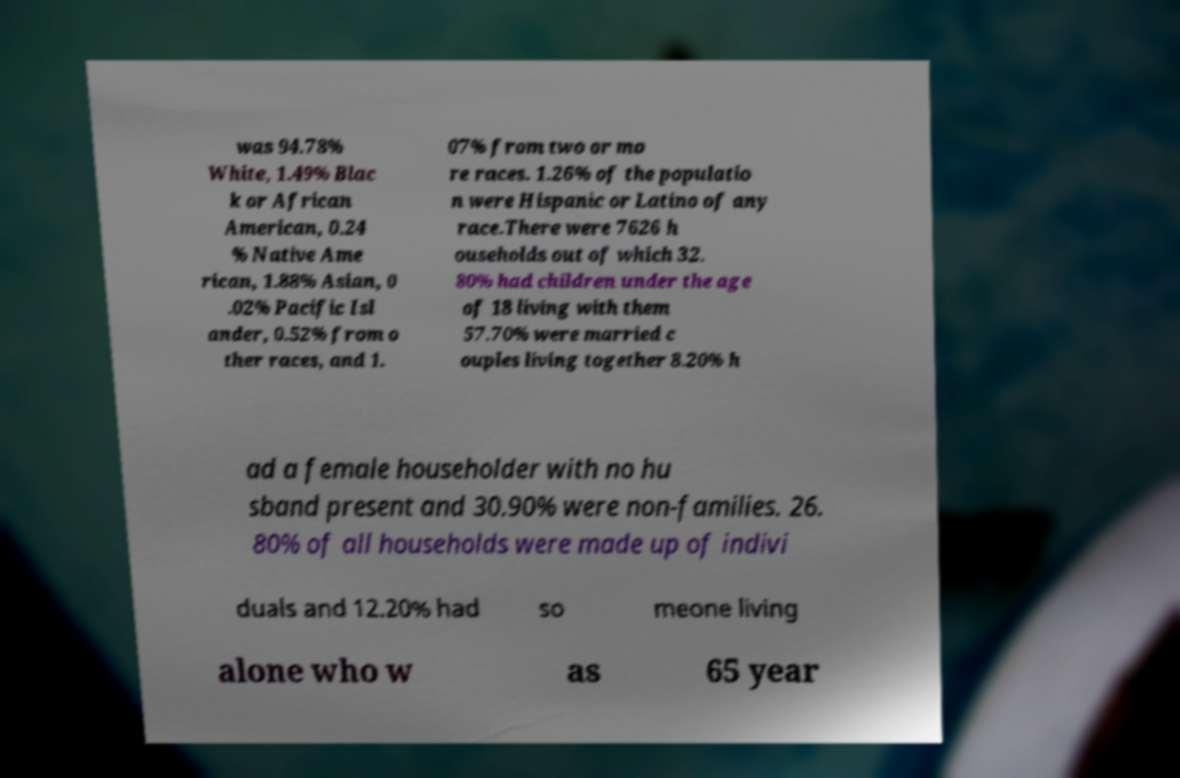Could you assist in decoding the text presented in this image and type it out clearly? was 94.78% White, 1.49% Blac k or African American, 0.24 % Native Ame rican, 1.88% Asian, 0 .02% Pacific Isl ander, 0.52% from o ther races, and 1. 07% from two or mo re races. 1.26% of the populatio n were Hispanic or Latino of any race.There were 7626 h ouseholds out of which 32. 80% had children under the age of 18 living with them 57.70% were married c ouples living together 8.20% h ad a female householder with no hu sband present and 30.90% were non-families. 26. 80% of all households were made up of indivi duals and 12.20% had so meone living alone who w as 65 year 